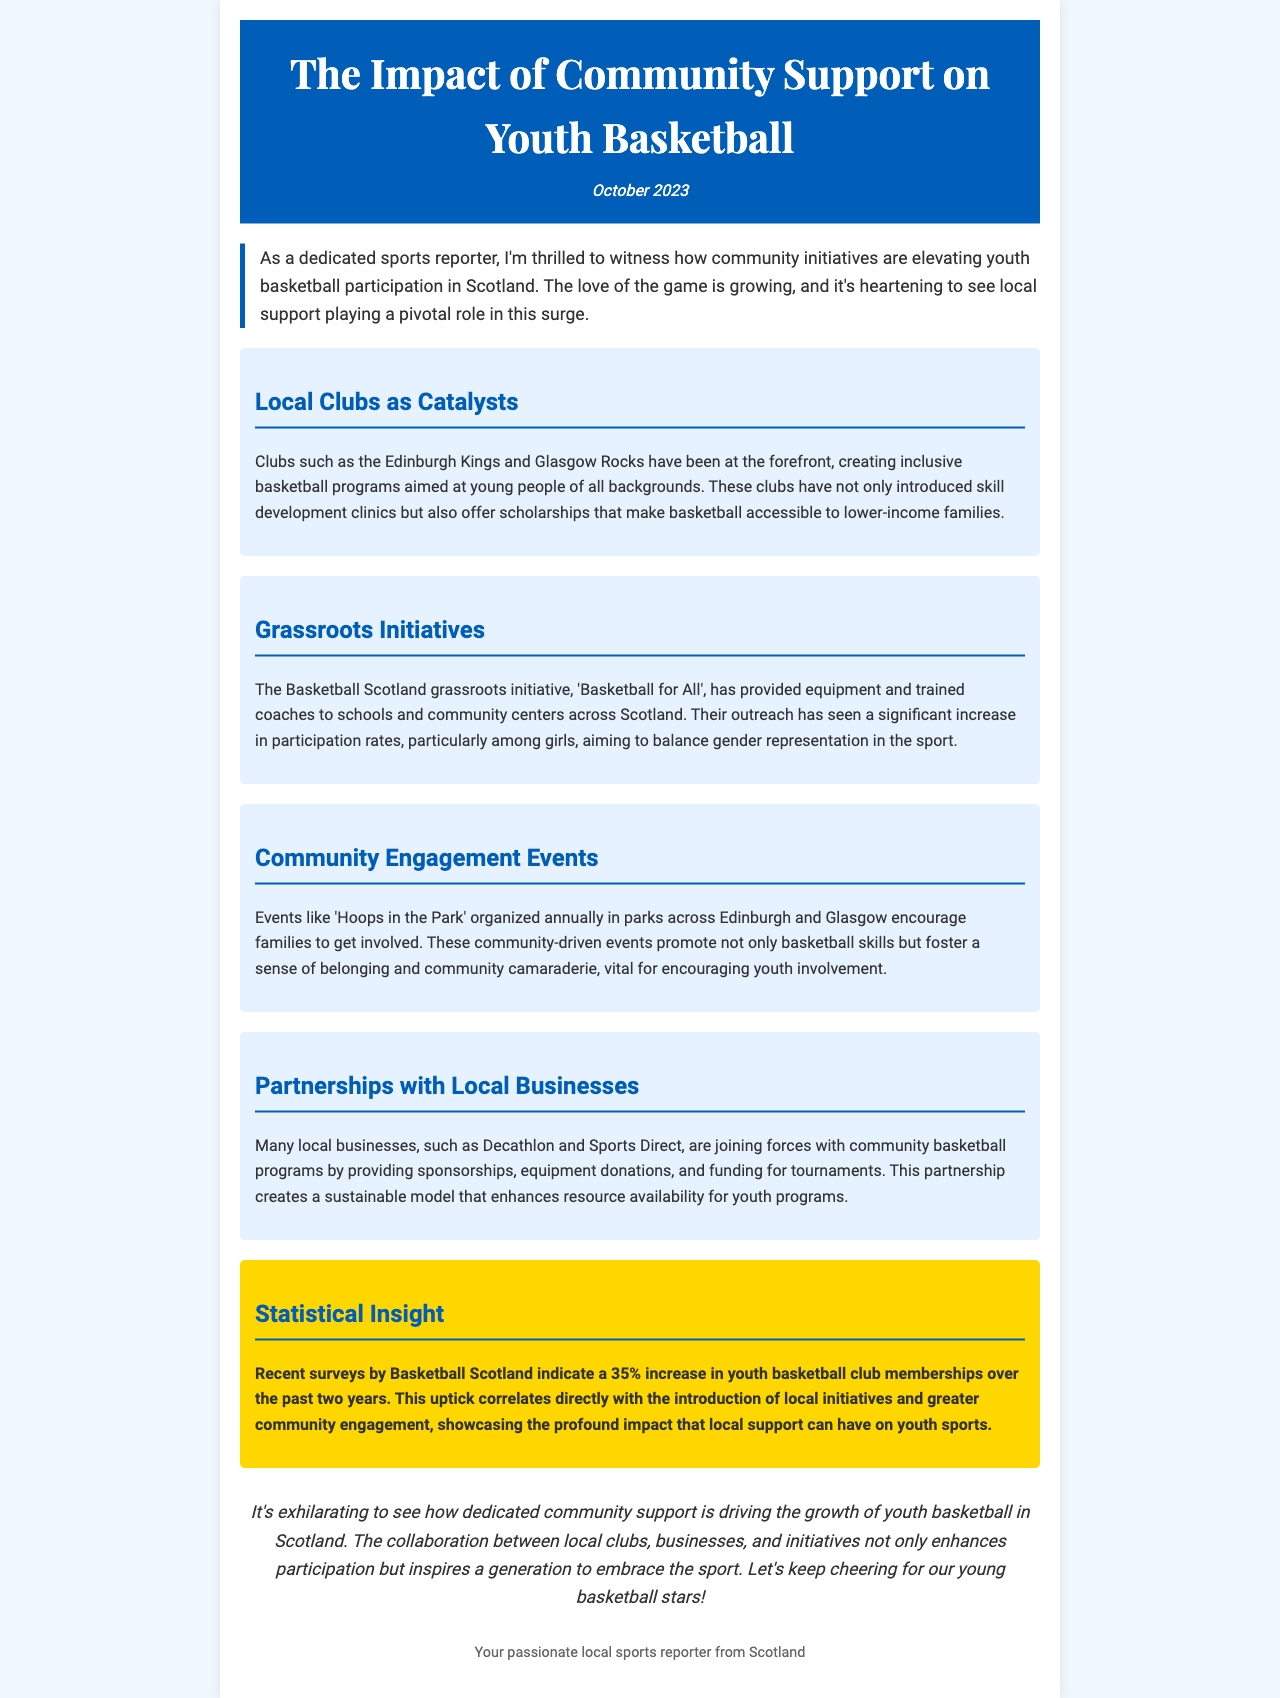What is the title of the newsletter? The title is stated prominently at the beginning of the document.
Answer: The Impact of Community Support on Youth Basketball When was the newsletter published? The publication date is mentioned in the header section of the document.
Answer: October 2023 What local initiative aims to enhance participation among girls? The document highlights specific initiatives aimed at promoting gender representation in basketball.
Answer: Basketball for All Which clubs are mentioned as leaders in creating youth programs? The document lists specific clubs that are creating inclusive basketball initiatives.
Answer: Edinburgh Kings and Glasgow Rocks What percentage increase in youth basketball club memberships is mentioned? The document provides a specific statistic regarding youth basketball club memberships.
Answer: 35% Name one local business that supports youth basketball programs. The document lists businesses involved in sponsorships and support for youth basketball.
Answer: Decathlon What community event encourages family involvement in basketball? The document describes events focused on community engagement and participation in basketball.
Answer: Hoops in the Park Why are community engagement events important? The document explains the significance of these events for youth involvement.
Answer: They foster a sense of belonging and community camaraderie What type of document is this? The specific nature of the document is indicated in its structure and content.
Answer: Newsletter 